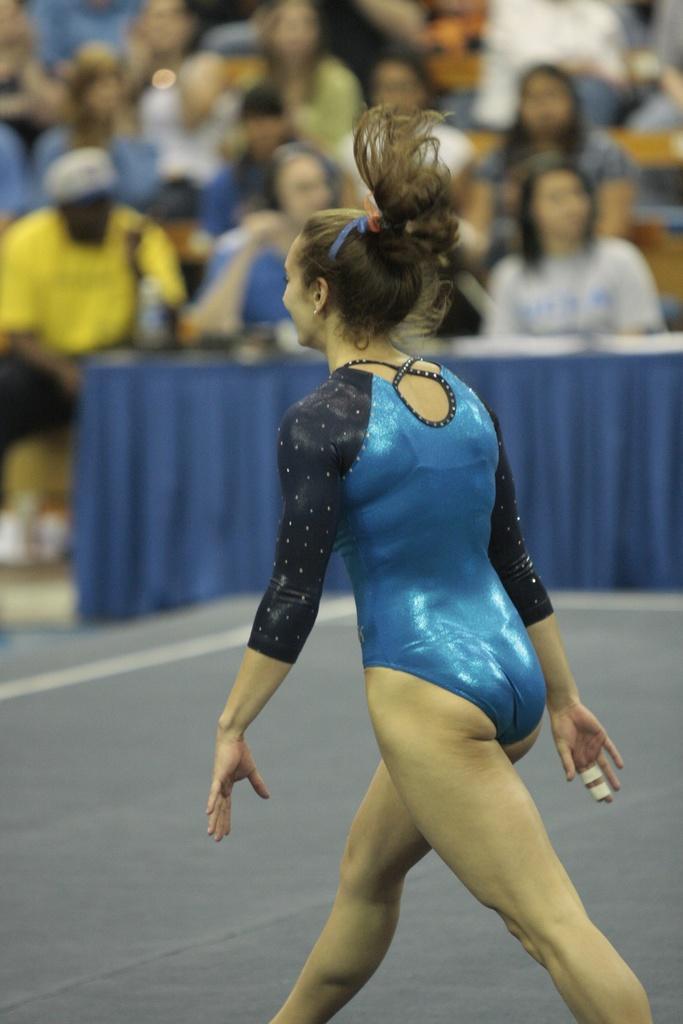In one or two sentences, can you explain what this image depicts? In this image in the foreground there is one woman who is walking, and in the background there are some people who are sitting and there is a table. And on the table there are some objects, at the bottom there is floor. 